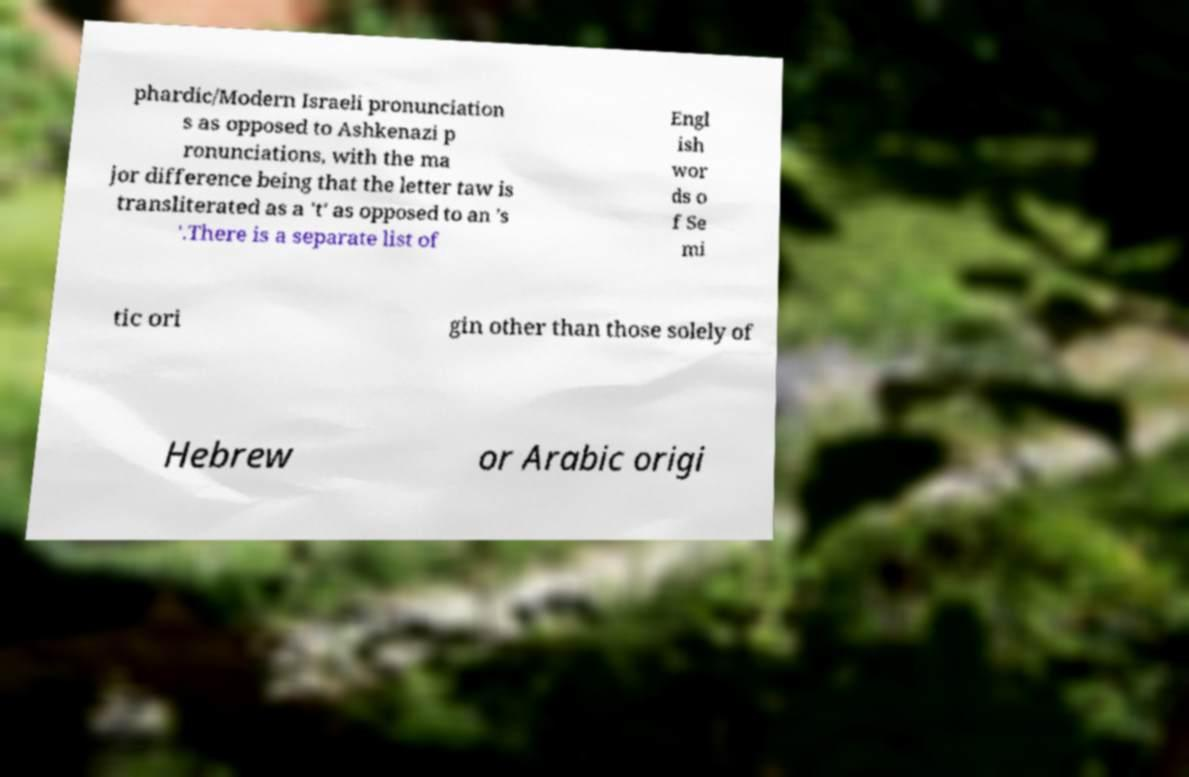Could you extract and type out the text from this image? phardic/Modern Israeli pronunciation s as opposed to Ashkenazi p ronunciations, with the ma jor difference being that the letter taw is transliterated as a 't' as opposed to an 's '.There is a separate list of Engl ish wor ds o f Se mi tic ori gin other than those solely of Hebrew or Arabic origi 